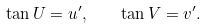Convert formula to latex. <formula><loc_0><loc_0><loc_500><loc_500>\tan U = u ^ { \prime } , \quad \tan V = v ^ { \prime } .</formula> 